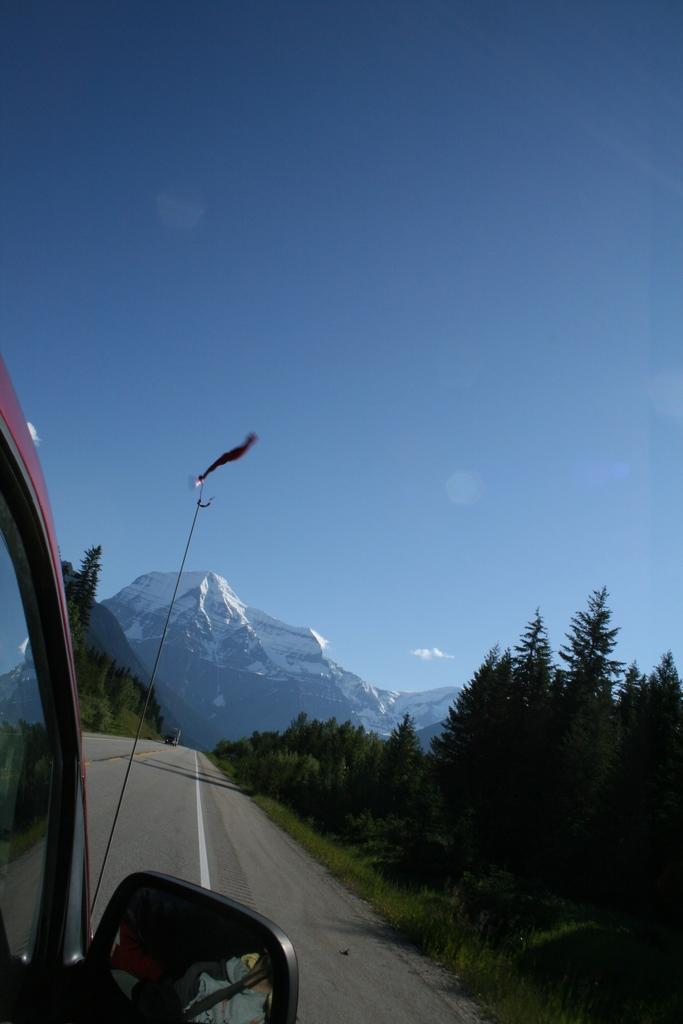What is the main subject of the image? There is a vehicle on the road in the image. What can be seen in the background of the image? There are trees, mountains, and other objects in the background of the image. What is visible in the sky in the image? The sky is visible in the background of the image. Can you tell me how many daughters are sitting next to the beggar in the image? There is no beggar or daughter present in the image; it features a vehicle on the road with a background of trees, mountains, and other objects. 